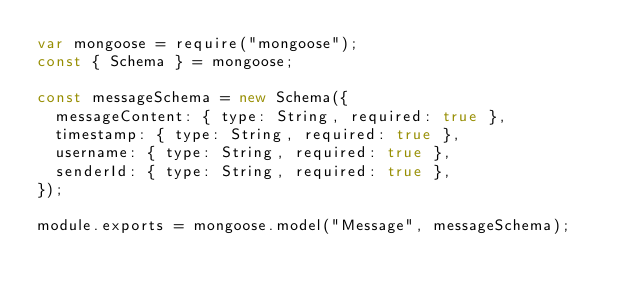<code> <loc_0><loc_0><loc_500><loc_500><_JavaScript_>var mongoose = require("mongoose");
const { Schema } = mongoose;

const messageSchema = new Schema({
  messageContent: { type: String, required: true },
  timestamp: { type: String, required: true },
  username: { type: String, required: true },
  senderId: { type: String, required: true },
});

module.exports = mongoose.model("Message", messageSchema);
</code> 